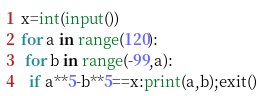Convert code to text. <code><loc_0><loc_0><loc_500><loc_500><_Python_>x=int(input())
for a in range(120):
 for b in range(-99,a):
  if a**5-b**5==x:print(a,b);exit()</code> 